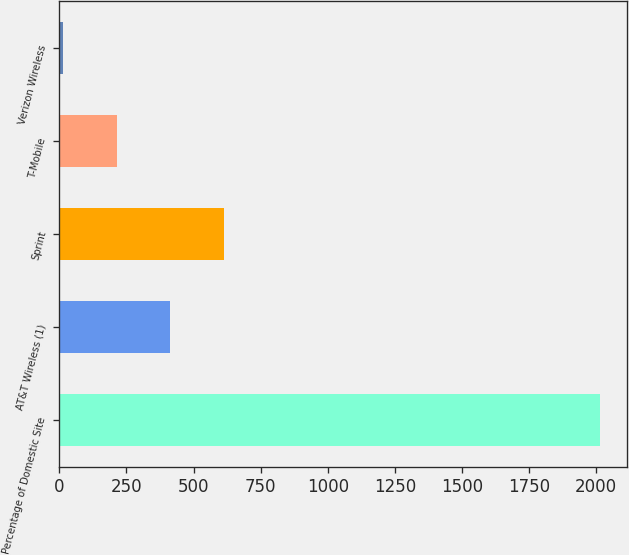Convert chart to OTSL. <chart><loc_0><loc_0><loc_500><loc_500><bar_chart><fcel>Percentage of Domestic Site<fcel>AT&T Wireless (1)<fcel>Sprint<fcel>T-Mobile<fcel>Verizon Wireless<nl><fcel>2013<fcel>413.24<fcel>613.21<fcel>213.27<fcel>13.3<nl></chart> 